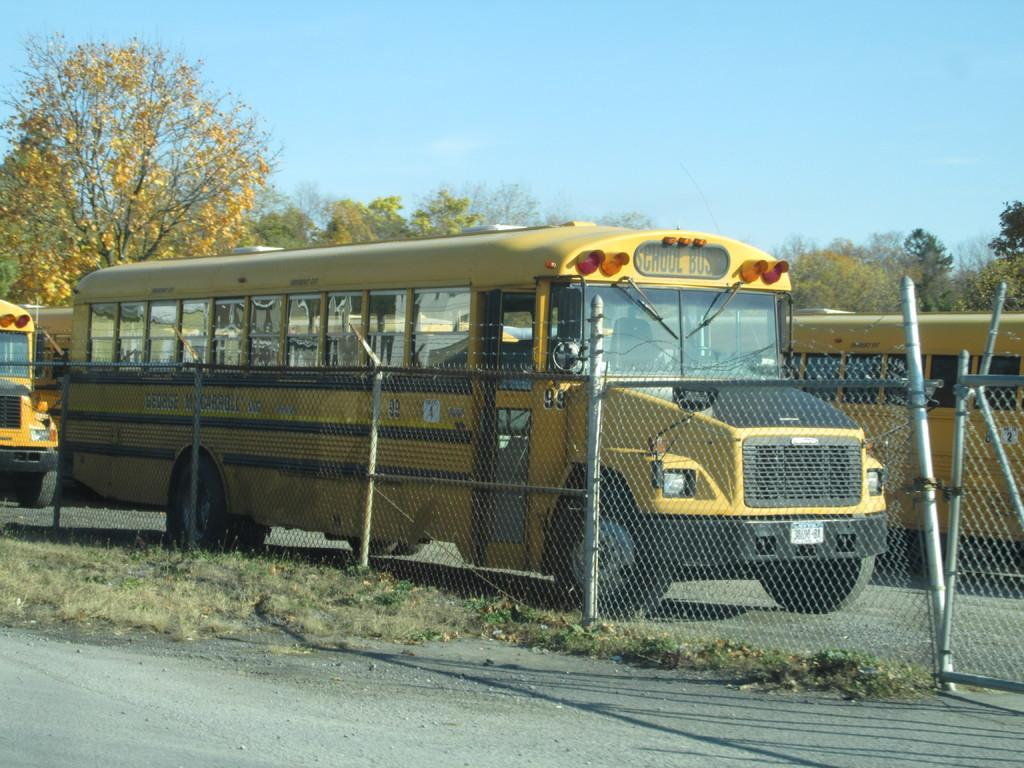Provide a one-sentence caption for the provided image. The yellow school bus ihas number 99 on the side. 